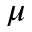<formula> <loc_0><loc_0><loc_500><loc_500>\mu</formula> 